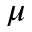<formula> <loc_0><loc_0><loc_500><loc_500>\mu</formula> 